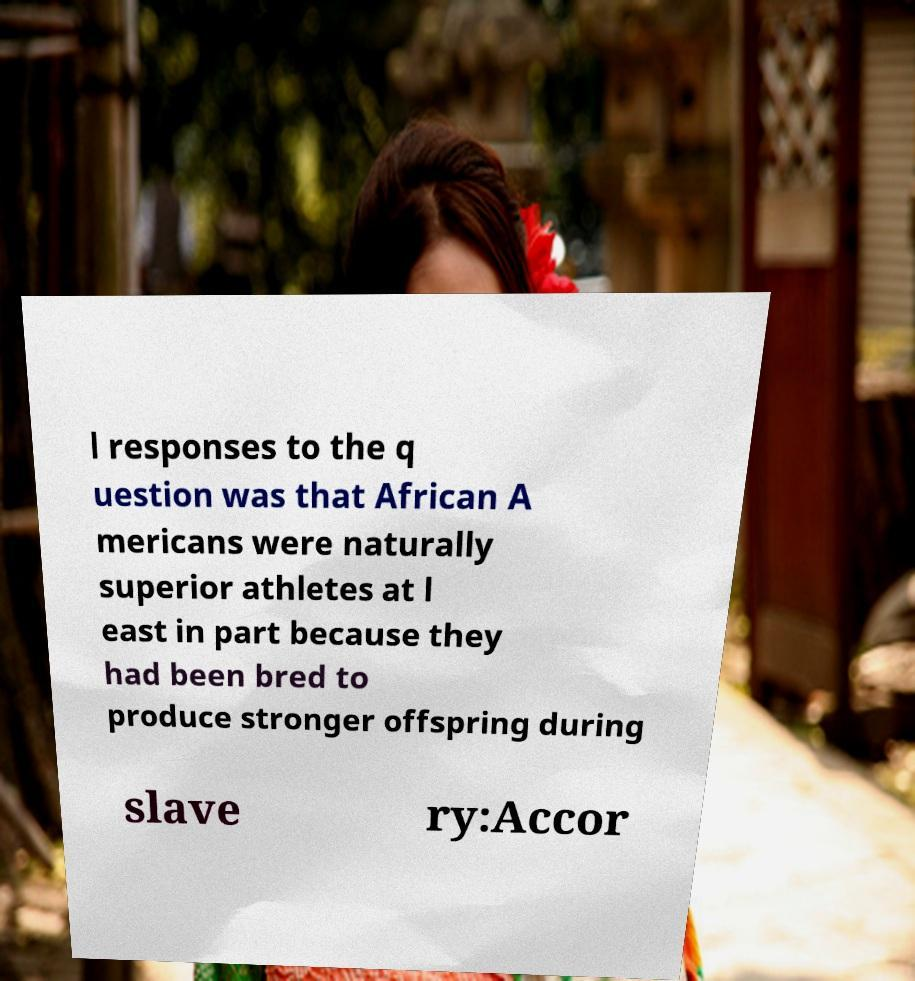Can you accurately transcribe the text from the provided image for me? l responses to the q uestion was that African A mericans were naturally superior athletes at l east in part because they had been bred to produce stronger offspring during slave ry:Accor 